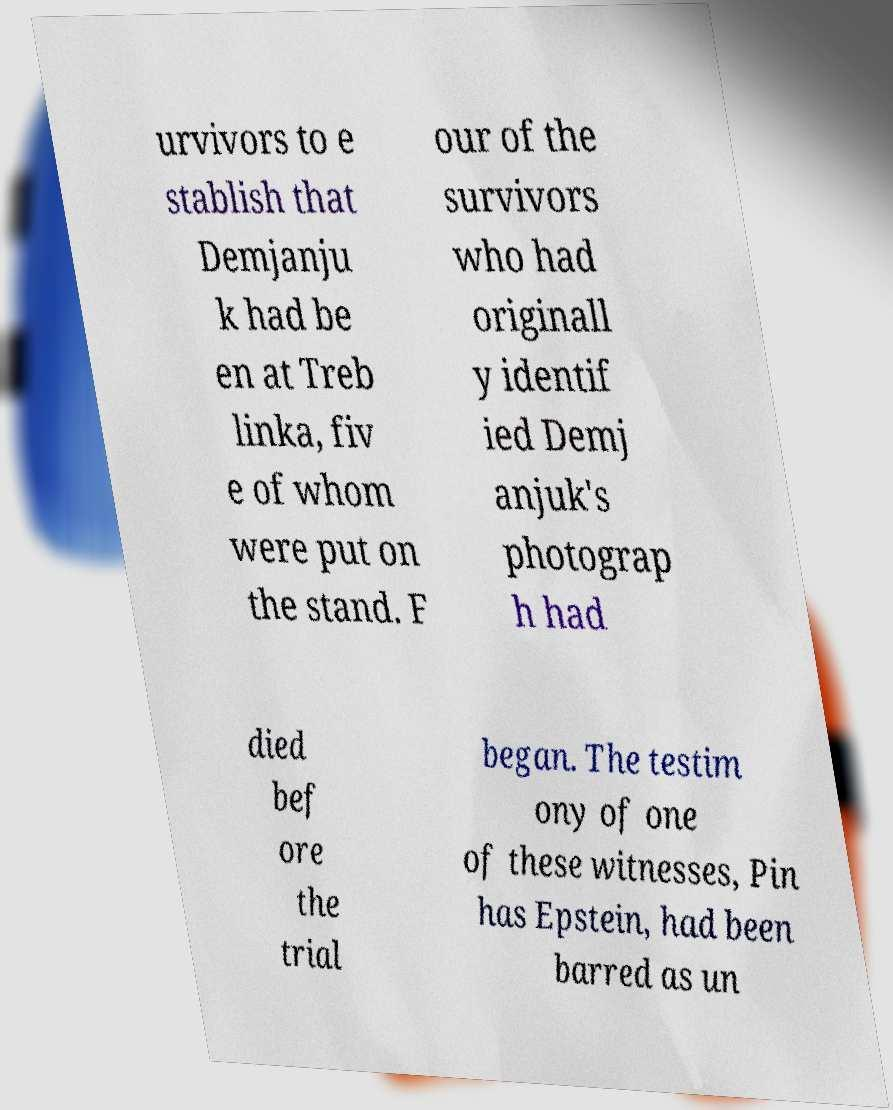Could you assist in decoding the text presented in this image and type it out clearly? urvivors to e stablish that Demjanju k had be en at Treb linka, fiv e of whom were put on the stand. F our of the survivors who had originall y identif ied Demj anjuk's photograp h had died bef ore the trial began. The testim ony of one of these witnesses, Pin has Epstein, had been barred as un 